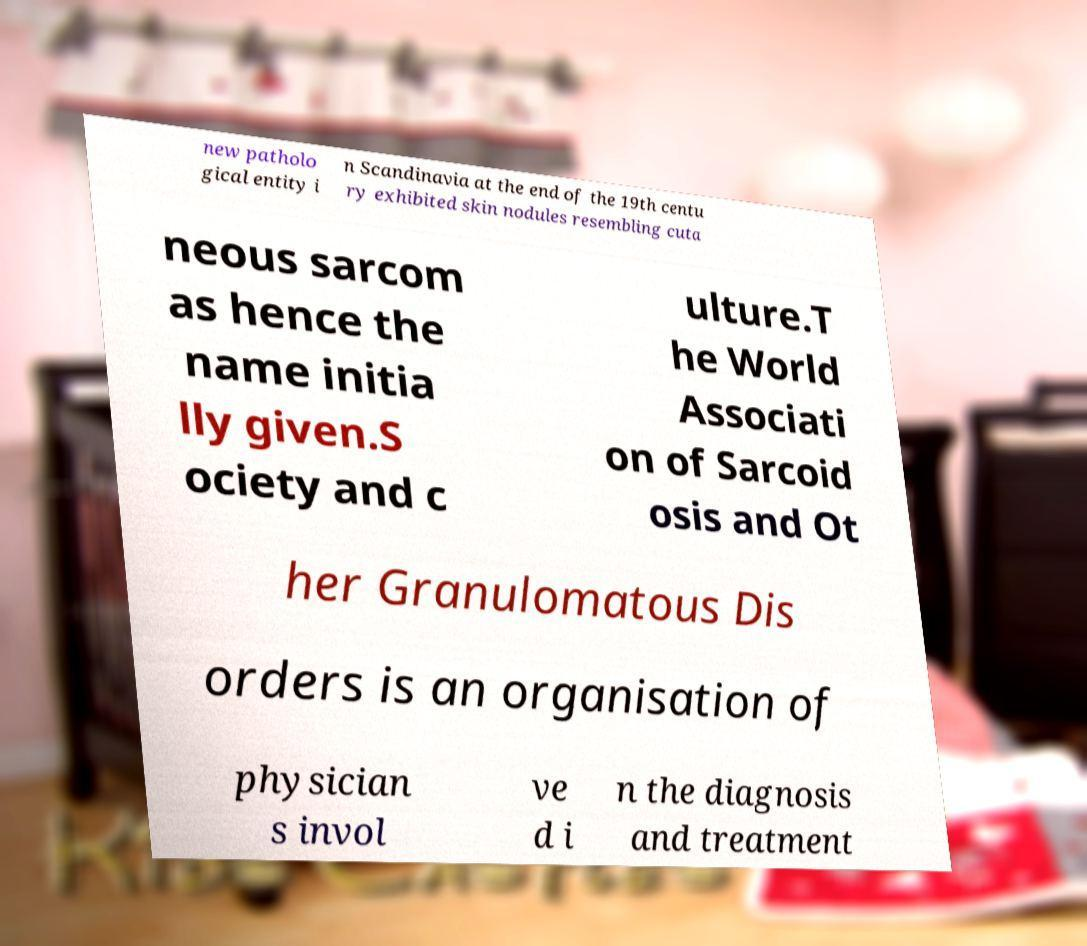Can you read and provide the text displayed in the image?This photo seems to have some interesting text. Can you extract and type it out for me? new patholo gical entity i n Scandinavia at the end of the 19th centu ry exhibited skin nodules resembling cuta neous sarcom as hence the name initia lly given.S ociety and c ulture.T he World Associati on of Sarcoid osis and Ot her Granulomatous Dis orders is an organisation of physician s invol ve d i n the diagnosis and treatment 